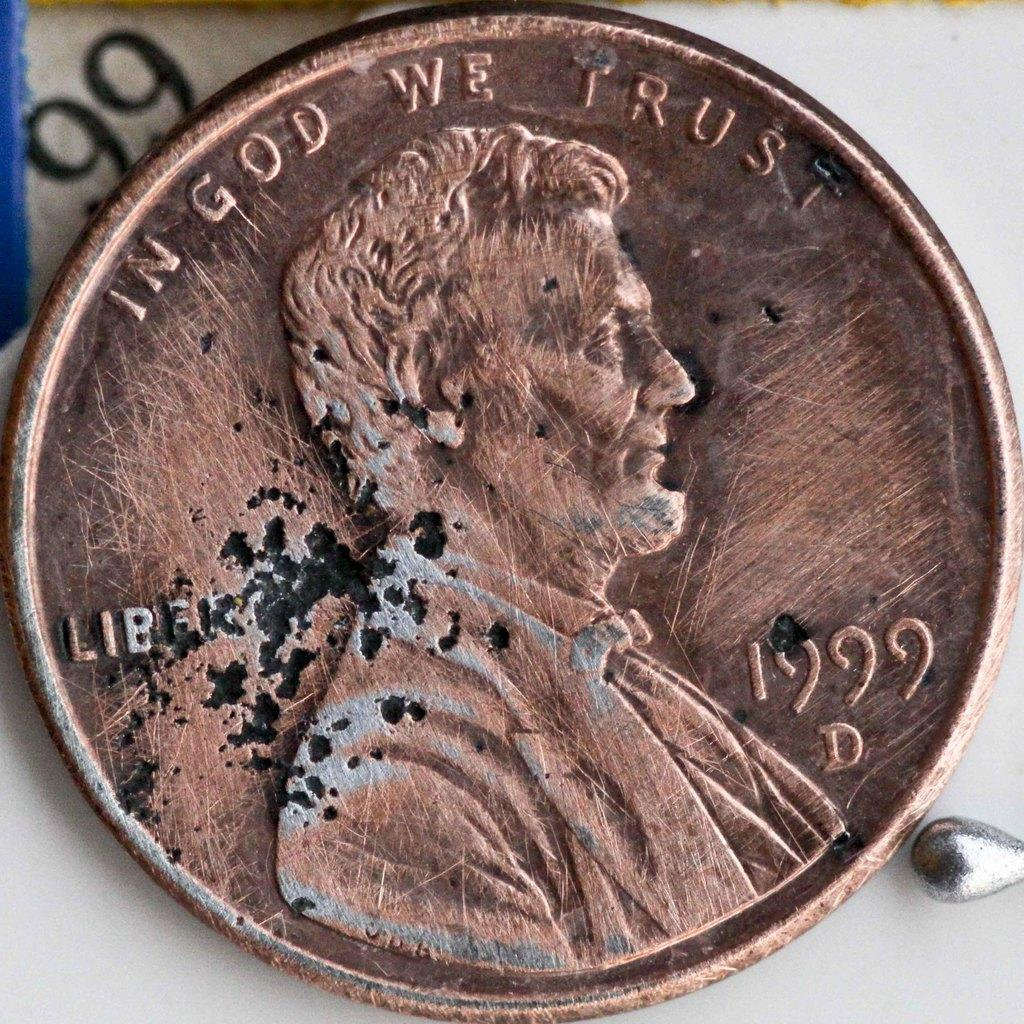<image>
Summarize the visual content of the image. A copper penny is from the year 1999. 